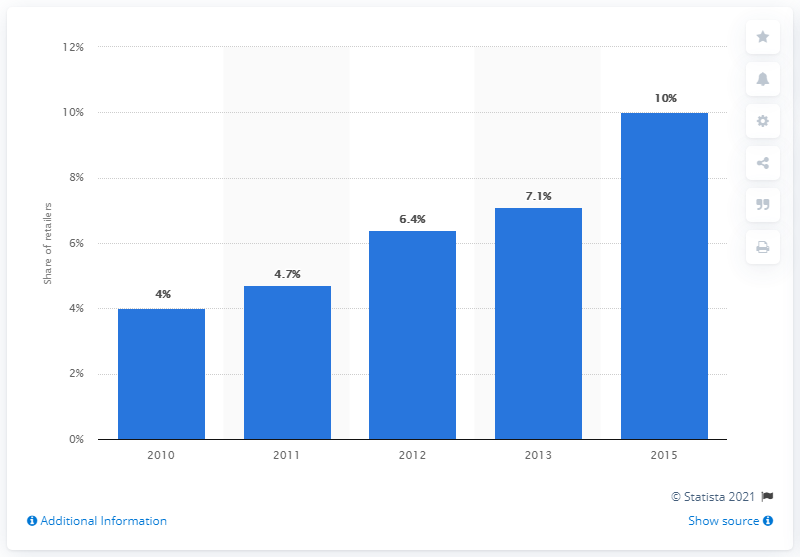List a handful of essential elements in this visual. In 2015, a significant portion of retailers offered same-day delivery for online orders. Specifically, approximately 10% of retailers provided this service. 